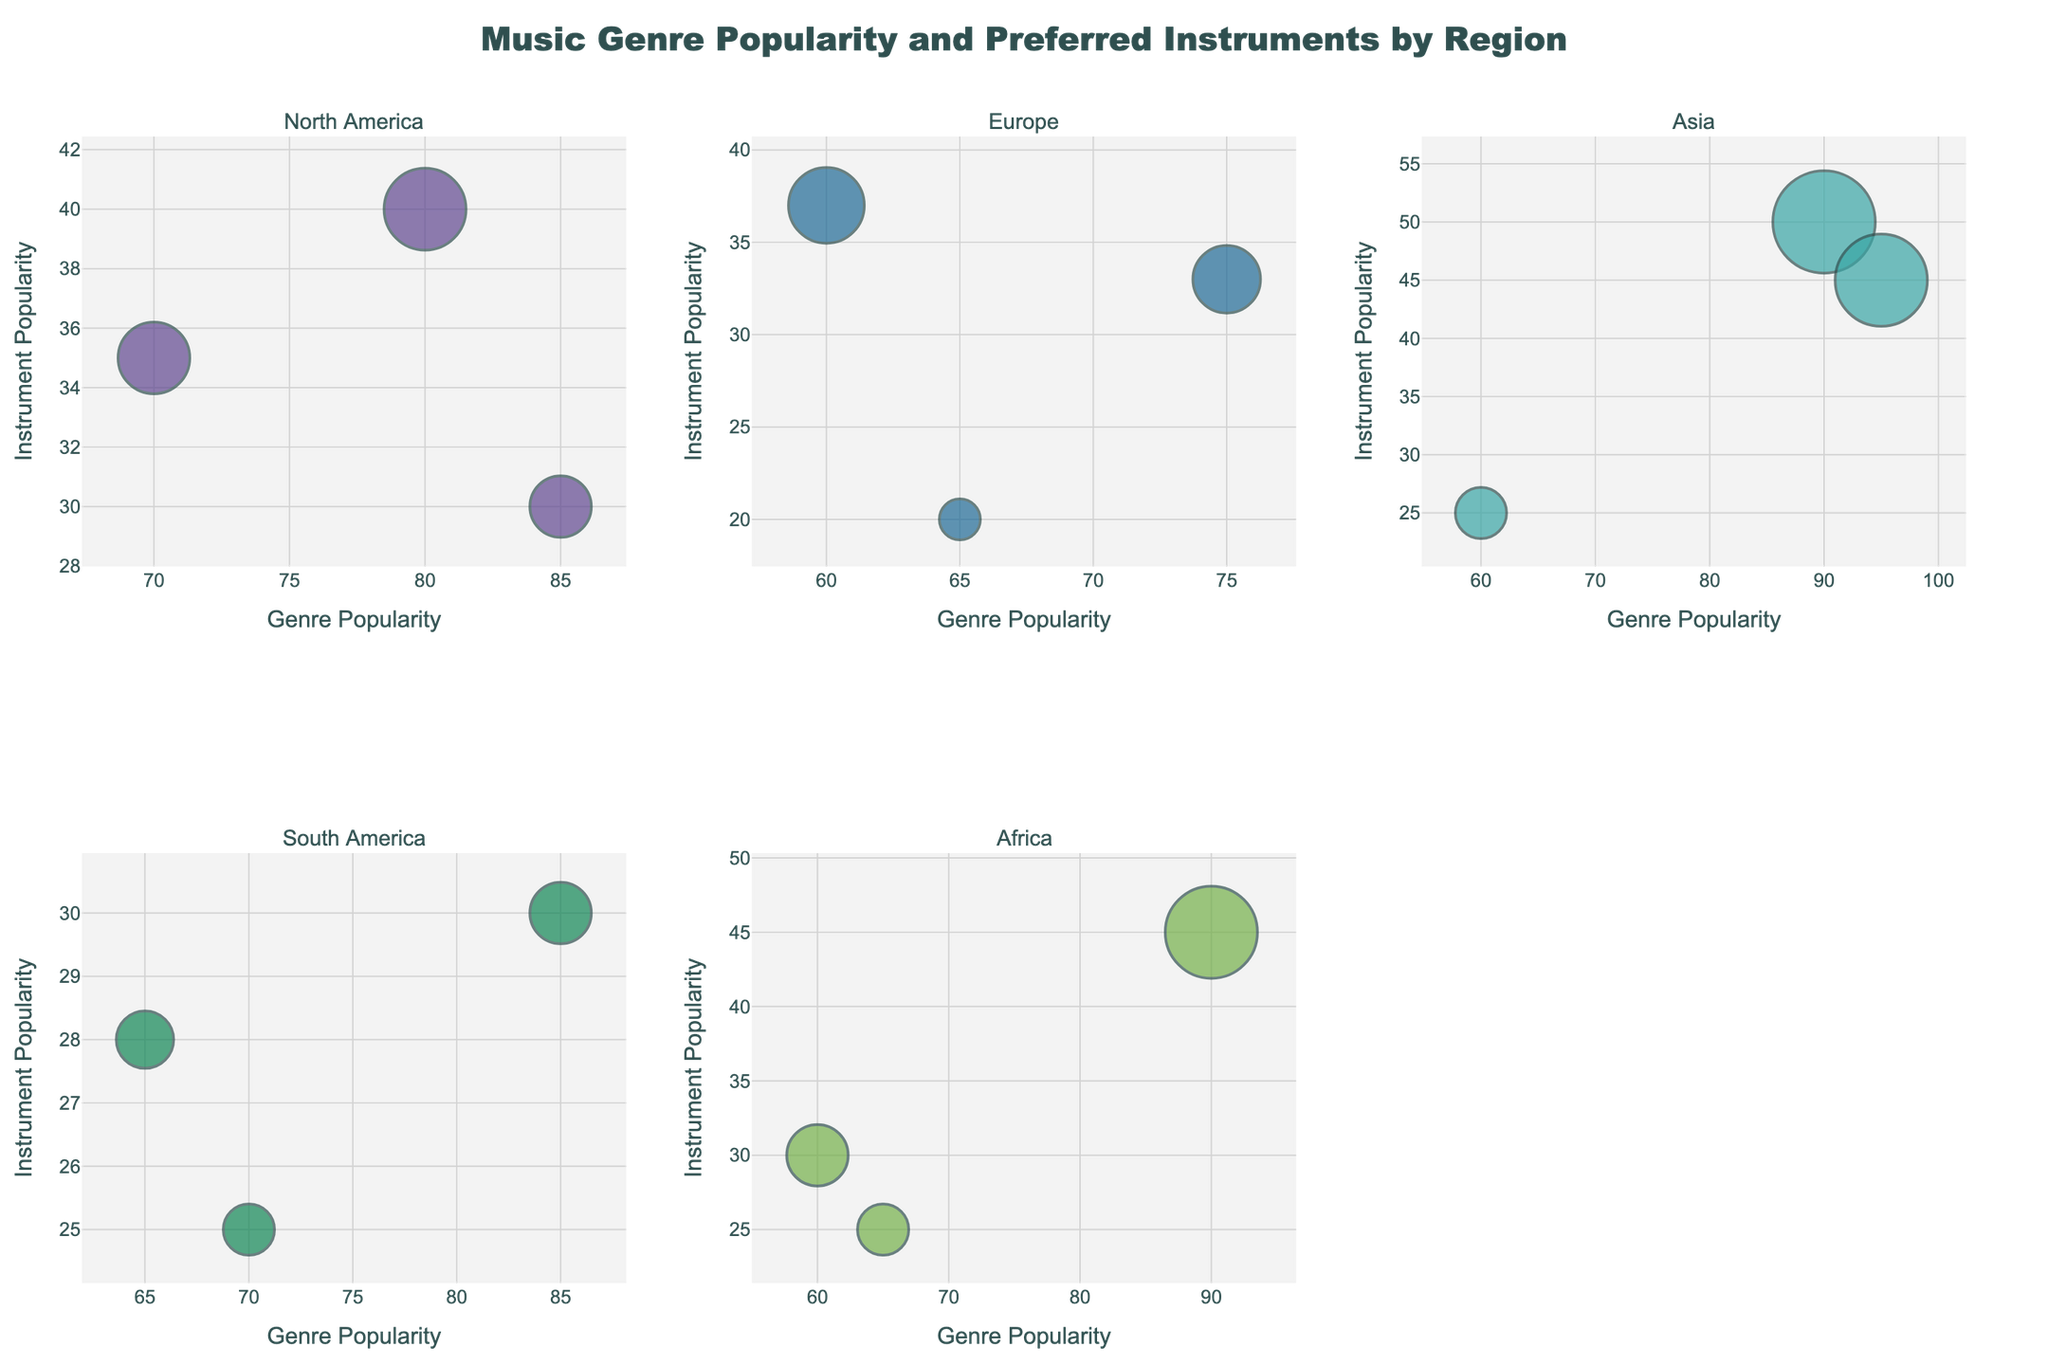What's the title of the chart? The title of the chart is located at the top and is usually indicated in larger text to summarize what the chart displays.
Answer: Music Genre Popularity and Preferred Instruments by Region How many regions are displayed in the subplot? The subplot titles indicate the number of regions. We can count these titles to determine the number of regions.
Answer: Six regions Which genre is the most popular in Asia? By looking at the Asia subplot, identify the genre with the highest x-axis value, which represents genre popularity.
Answer: K-Pop Which instrument is preferred for Hip Hop in North America? In the North America subplot, locate the bubble that represents Hip Hop and note the text associated with this bubble.
Answer: Drum Machine What is the region with the most popular Afrobeats genre? Locate the subplot where Afrobeats is represented and identify the corresponding region title.
Answer: Africa Compare the popularity of Pop in North America and Europe. Which one is higher? Find the bubbles representing Pop in both the North America and Europe subplots and compare their x-axis values, which represent popularity.
Answer: North America Which region shows the highest instrument popularity for the Piano? Identify the bubbles labeled with Piano in all subplots and compare their y-axis values to determine which is the highest.
Answer: Asia Is there a region where Pop is not the most popular genre? Check each subplot to see if there is any region where another genre has a higher x-axis value than Pop.
Answer: South America What is the preferred instrument with the highest instrument popularity across all regions? Compare the y-axis values of all bubbles and identify the instrument with the highest value.
Answer: Synthesizer What is the genre with both high genre popularity and high instrument popularity in Africa? In the Africa subplot, look for the bubble that is positioned high on both the x-axis and y-axis, indicating both high genre and instrument popularity.
Answer: Afrobeats 